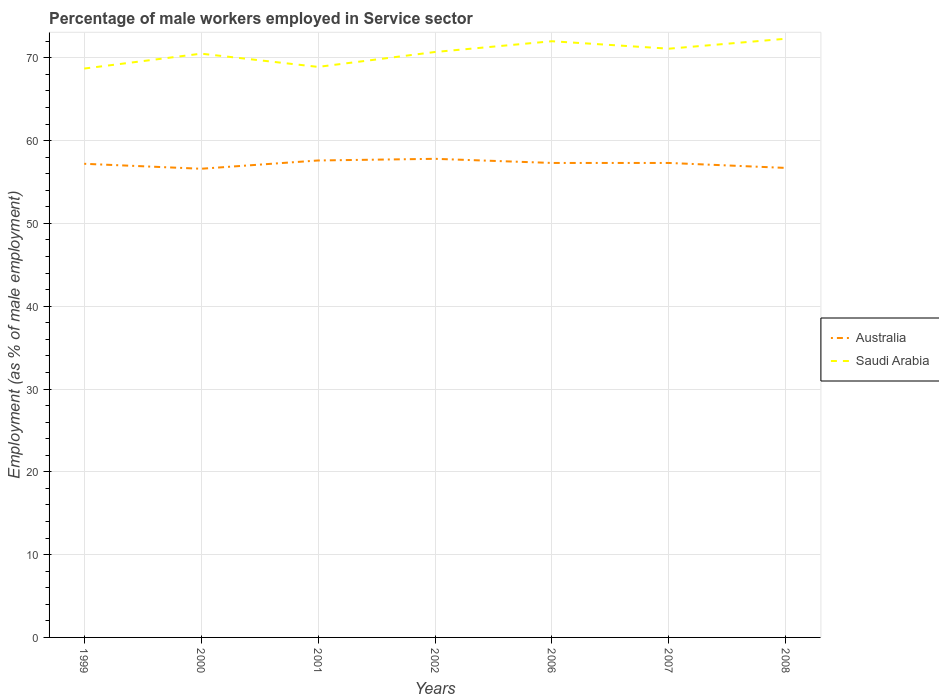Does the line corresponding to Saudi Arabia intersect with the line corresponding to Australia?
Give a very brief answer. No. Across all years, what is the maximum percentage of male workers employed in Service sector in Saudi Arabia?
Provide a short and direct response. 68.7. In which year was the percentage of male workers employed in Service sector in Australia maximum?
Provide a succinct answer. 2000. What is the total percentage of male workers employed in Service sector in Australia in the graph?
Give a very brief answer. 0.3. What is the difference between the highest and the second highest percentage of male workers employed in Service sector in Australia?
Offer a very short reply. 1.2. How many lines are there?
Offer a terse response. 2. How many years are there in the graph?
Offer a terse response. 7. What is the title of the graph?
Your answer should be very brief. Percentage of male workers employed in Service sector. Does "Malaysia" appear as one of the legend labels in the graph?
Keep it short and to the point. No. What is the label or title of the Y-axis?
Provide a succinct answer. Employment (as % of male employment). What is the Employment (as % of male employment) of Australia in 1999?
Make the answer very short. 57.2. What is the Employment (as % of male employment) in Saudi Arabia in 1999?
Your response must be concise. 68.7. What is the Employment (as % of male employment) of Australia in 2000?
Your answer should be very brief. 56.6. What is the Employment (as % of male employment) in Saudi Arabia in 2000?
Offer a very short reply. 70.5. What is the Employment (as % of male employment) in Australia in 2001?
Provide a succinct answer. 57.6. What is the Employment (as % of male employment) of Saudi Arabia in 2001?
Your answer should be compact. 68.9. What is the Employment (as % of male employment) of Australia in 2002?
Provide a succinct answer. 57.8. What is the Employment (as % of male employment) of Saudi Arabia in 2002?
Provide a succinct answer. 70.7. What is the Employment (as % of male employment) of Australia in 2006?
Keep it short and to the point. 57.3. What is the Employment (as % of male employment) of Australia in 2007?
Make the answer very short. 57.3. What is the Employment (as % of male employment) in Saudi Arabia in 2007?
Your answer should be compact. 71.1. What is the Employment (as % of male employment) of Australia in 2008?
Provide a succinct answer. 56.7. What is the Employment (as % of male employment) of Saudi Arabia in 2008?
Offer a very short reply. 72.3. Across all years, what is the maximum Employment (as % of male employment) in Australia?
Keep it short and to the point. 57.8. Across all years, what is the maximum Employment (as % of male employment) of Saudi Arabia?
Provide a short and direct response. 72.3. Across all years, what is the minimum Employment (as % of male employment) in Australia?
Make the answer very short. 56.6. Across all years, what is the minimum Employment (as % of male employment) of Saudi Arabia?
Ensure brevity in your answer.  68.7. What is the total Employment (as % of male employment) of Australia in the graph?
Make the answer very short. 400.5. What is the total Employment (as % of male employment) of Saudi Arabia in the graph?
Your response must be concise. 494.2. What is the difference between the Employment (as % of male employment) of Saudi Arabia in 1999 and that in 2000?
Your answer should be very brief. -1.8. What is the difference between the Employment (as % of male employment) of Australia in 1999 and that in 2002?
Offer a terse response. -0.6. What is the difference between the Employment (as % of male employment) in Saudi Arabia in 1999 and that in 2002?
Offer a terse response. -2. What is the difference between the Employment (as % of male employment) in Saudi Arabia in 1999 and that in 2006?
Provide a short and direct response. -3.3. What is the difference between the Employment (as % of male employment) of Australia in 1999 and that in 2007?
Provide a succinct answer. -0.1. What is the difference between the Employment (as % of male employment) in Saudi Arabia in 1999 and that in 2007?
Offer a terse response. -2.4. What is the difference between the Employment (as % of male employment) in Australia in 1999 and that in 2008?
Your answer should be compact. 0.5. What is the difference between the Employment (as % of male employment) of Saudi Arabia in 1999 and that in 2008?
Your answer should be very brief. -3.6. What is the difference between the Employment (as % of male employment) in Saudi Arabia in 2000 and that in 2001?
Keep it short and to the point. 1.6. What is the difference between the Employment (as % of male employment) of Australia in 2000 and that in 2002?
Offer a very short reply. -1.2. What is the difference between the Employment (as % of male employment) of Saudi Arabia in 2000 and that in 2002?
Provide a short and direct response. -0.2. What is the difference between the Employment (as % of male employment) in Australia in 2000 and that in 2006?
Provide a succinct answer. -0.7. What is the difference between the Employment (as % of male employment) in Saudi Arabia in 2000 and that in 2007?
Your answer should be very brief. -0.6. What is the difference between the Employment (as % of male employment) in Saudi Arabia in 2000 and that in 2008?
Offer a terse response. -1.8. What is the difference between the Employment (as % of male employment) in Australia in 2001 and that in 2002?
Offer a terse response. -0.2. What is the difference between the Employment (as % of male employment) in Saudi Arabia in 2001 and that in 2002?
Keep it short and to the point. -1.8. What is the difference between the Employment (as % of male employment) of Australia in 2001 and that in 2006?
Your response must be concise. 0.3. What is the difference between the Employment (as % of male employment) of Australia in 2001 and that in 2007?
Ensure brevity in your answer.  0.3. What is the difference between the Employment (as % of male employment) in Australia in 2001 and that in 2008?
Give a very brief answer. 0.9. What is the difference between the Employment (as % of male employment) in Australia in 2002 and that in 2006?
Provide a succinct answer. 0.5. What is the difference between the Employment (as % of male employment) of Australia in 2002 and that in 2007?
Keep it short and to the point. 0.5. What is the difference between the Employment (as % of male employment) of Saudi Arabia in 2002 and that in 2008?
Provide a short and direct response. -1.6. What is the difference between the Employment (as % of male employment) of Australia in 2007 and that in 2008?
Keep it short and to the point. 0.6. What is the difference between the Employment (as % of male employment) of Saudi Arabia in 2007 and that in 2008?
Provide a succinct answer. -1.2. What is the difference between the Employment (as % of male employment) of Australia in 1999 and the Employment (as % of male employment) of Saudi Arabia in 2000?
Your response must be concise. -13.3. What is the difference between the Employment (as % of male employment) in Australia in 1999 and the Employment (as % of male employment) in Saudi Arabia in 2002?
Your response must be concise. -13.5. What is the difference between the Employment (as % of male employment) in Australia in 1999 and the Employment (as % of male employment) in Saudi Arabia in 2006?
Offer a very short reply. -14.8. What is the difference between the Employment (as % of male employment) of Australia in 1999 and the Employment (as % of male employment) of Saudi Arabia in 2007?
Offer a very short reply. -13.9. What is the difference between the Employment (as % of male employment) of Australia in 1999 and the Employment (as % of male employment) of Saudi Arabia in 2008?
Offer a terse response. -15.1. What is the difference between the Employment (as % of male employment) in Australia in 2000 and the Employment (as % of male employment) in Saudi Arabia in 2002?
Ensure brevity in your answer.  -14.1. What is the difference between the Employment (as % of male employment) in Australia in 2000 and the Employment (as % of male employment) in Saudi Arabia in 2006?
Provide a succinct answer. -15.4. What is the difference between the Employment (as % of male employment) in Australia in 2000 and the Employment (as % of male employment) in Saudi Arabia in 2008?
Your answer should be very brief. -15.7. What is the difference between the Employment (as % of male employment) of Australia in 2001 and the Employment (as % of male employment) of Saudi Arabia in 2002?
Give a very brief answer. -13.1. What is the difference between the Employment (as % of male employment) in Australia in 2001 and the Employment (as % of male employment) in Saudi Arabia in 2006?
Your response must be concise. -14.4. What is the difference between the Employment (as % of male employment) in Australia in 2001 and the Employment (as % of male employment) in Saudi Arabia in 2007?
Your answer should be compact. -13.5. What is the difference between the Employment (as % of male employment) of Australia in 2001 and the Employment (as % of male employment) of Saudi Arabia in 2008?
Make the answer very short. -14.7. What is the difference between the Employment (as % of male employment) in Australia in 2006 and the Employment (as % of male employment) in Saudi Arabia in 2008?
Your answer should be compact. -15. What is the average Employment (as % of male employment) in Australia per year?
Your response must be concise. 57.21. What is the average Employment (as % of male employment) of Saudi Arabia per year?
Keep it short and to the point. 70.6. In the year 2000, what is the difference between the Employment (as % of male employment) in Australia and Employment (as % of male employment) in Saudi Arabia?
Keep it short and to the point. -13.9. In the year 2001, what is the difference between the Employment (as % of male employment) in Australia and Employment (as % of male employment) in Saudi Arabia?
Give a very brief answer. -11.3. In the year 2002, what is the difference between the Employment (as % of male employment) in Australia and Employment (as % of male employment) in Saudi Arabia?
Provide a short and direct response. -12.9. In the year 2006, what is the difference between the Employment (as % of male employment) of Australia and Employment (as % of male employment) of Saudi Arabia?
Give a very brief answer. -14.7. In the year 2008, what is the difference between the Employment (as % of male employment) in Australia and Employment (as % of male employment) in Saudi Arabia?
Offer a very short reply. -15.6. What is the ratio of the Employment (as % of male employment) in Australia in 1999 to that in 2000?
Your answer should be very brief. 1.01. What is the ratio of the Employment (as % of male employment) in Saudi Arabia in 1999 to that in 2000?
Ensure brevity in your answer.  0.97. What is the ratio of the Employment (as % of male employment) of Australia in 1999 to that in 2001?
Your response must be concise. 0.99. What is the ratio of the Employment (as % of male employment) of Saudi Arabia in 1999 to that in 2002?
Provide a short and direct response. 0.97. What is the ratio of the Employment (as % of male employment) of Australia in 1999 to that in 2006?
Your answer should be compact. 1. What is the ratio of the Employment (as % of male employment) in Saudi Arabia in 1999 to that in 2006?
Keep it short and to the point. 0.95. What is the ratio of the Employment (as % of male employment) of Australia in 1999 to that in 2007?
Provide a short and direct response. 1. What is the ratio of the Employment (as % of male employment) of Saudi Arabia in 1999 to that in 2007?
Keep it short and to the point. 0.97. What is the ratio of the Employment (as % of male employment) of Australia in 1999 to that in 2008?
Offer a terse response. 1.01. What is the ratio of the Employment (as % of male employment) in Saudi Arabia in 1999 to that in 2008?
Give a very brief answer. 0.95. What is the ratio of the Employment (as % of male employment) of Australia in 2000 to that in 2001?
Offer a very short reply. 0.98. What is the ratio of the Employment (as % of male employment) in Saudi Arabia in 2000 to that in 2001?
Provide a short and direct response. 1.02. What is the ratio of the Employment (as % of male employment) in Australia in 2000 to that in 2002?
Give a very brief answer. 0.98. What is the ratio of the Employment (as % of male employment) of Saudi Arabia in 2000 to that in 2002?
Offer a terse response. 1. What is the ratio of the Employment (as % of male employment) of Saudi Arabia in 2000 to that in 2006?
Ensure brevity in your answer.  0.98. What is the ratio of the Employment (as % of male employment) in Saudi Arabia in 2000 to that in 2007?
Your answer should be very brief. 0.99. What is the ratio of the Employment (as % of male employment) in Australia in 2000 to that in 2008?
Provide a succinct answer. 1. What is the ratio of the Employment (as % of male employment) in Saudi Arabia in 2000 to that in 2008?
Ensure brevity in your answer.  0.98. What is the ratio of the Employment (as % of male employment) of Saudi Arabia in 2001 to that in 2002?
Make the answer very short. 0.97. What is the ratio of the Employment (as % of male employment) in Australia in 2001 to that in 2006?
Ensure brevity in your answer.  1.01. What is the ratio of the Employment (as % of male employment) in Saudi Arabia in 2001 to that in 2006?
Ensure brevity in your answer.  0.96. What is the ratio of the Employment (as % of male employment) of Australia in 2001 to that in 2007?
Your answer should be compact. 1.01. What is the ratio of the Employment (as % of male employment) of Saudi Arabia in 2001 to that in 2007?
Your answer should be compact. 0.97. What is the ratio of the Employment (as % of male employment) in Australia in 2001 to that in 2008?
Provide a succinct answer. 1.02. What is the ratio of the Employment (as % of male employment) of Saudi Arabia in 2001 to that in 2008?
Ensure brevity in your answer.  0.95. What is the ratio of the Employment (as % of male employment) in Australia in 2002 to that in 2006?
Your answer should be compact. 1.01. What is the ratio of the Employment (as % of male employment) of Saudi Arabia in 2002 to that in 2006?
Ensure brevity in your answer.  0.98. What is the ratio of the Employment (as % of male employment) of Australia in 2002 to that in 2007?
Ensure brevity in your answer.  1.01. What is the ratio of the Employment (as % of male employment) of Australia in 2002 to that in 2008?
Your answer should be compact. 1.02. What is the ratio of the Employment (as % of male employment) in Saudi Arabia in 2002 to that in 2008?
Your response must be concise. 0.98. What is the ratio of the Employment (as % of male employment) in Saudi Arabia in 2006 to that in 2007?
Offer a very short reply. 1.01. What is the ratio of the Employment (as % of male employment) in Australia in 2006 to that in 2008?
Provide a short and direct response. 1.01. What is the ratio of the Employment (as % of male employment) of Australia in 2007 to that in 2008?
Provide a short and direct response. 1.01. What is the ratio of the Employment (as % of male employment) of Saudi Arabia in 2007 to that in 2008?
Provide a succinct answer. 0.98. 